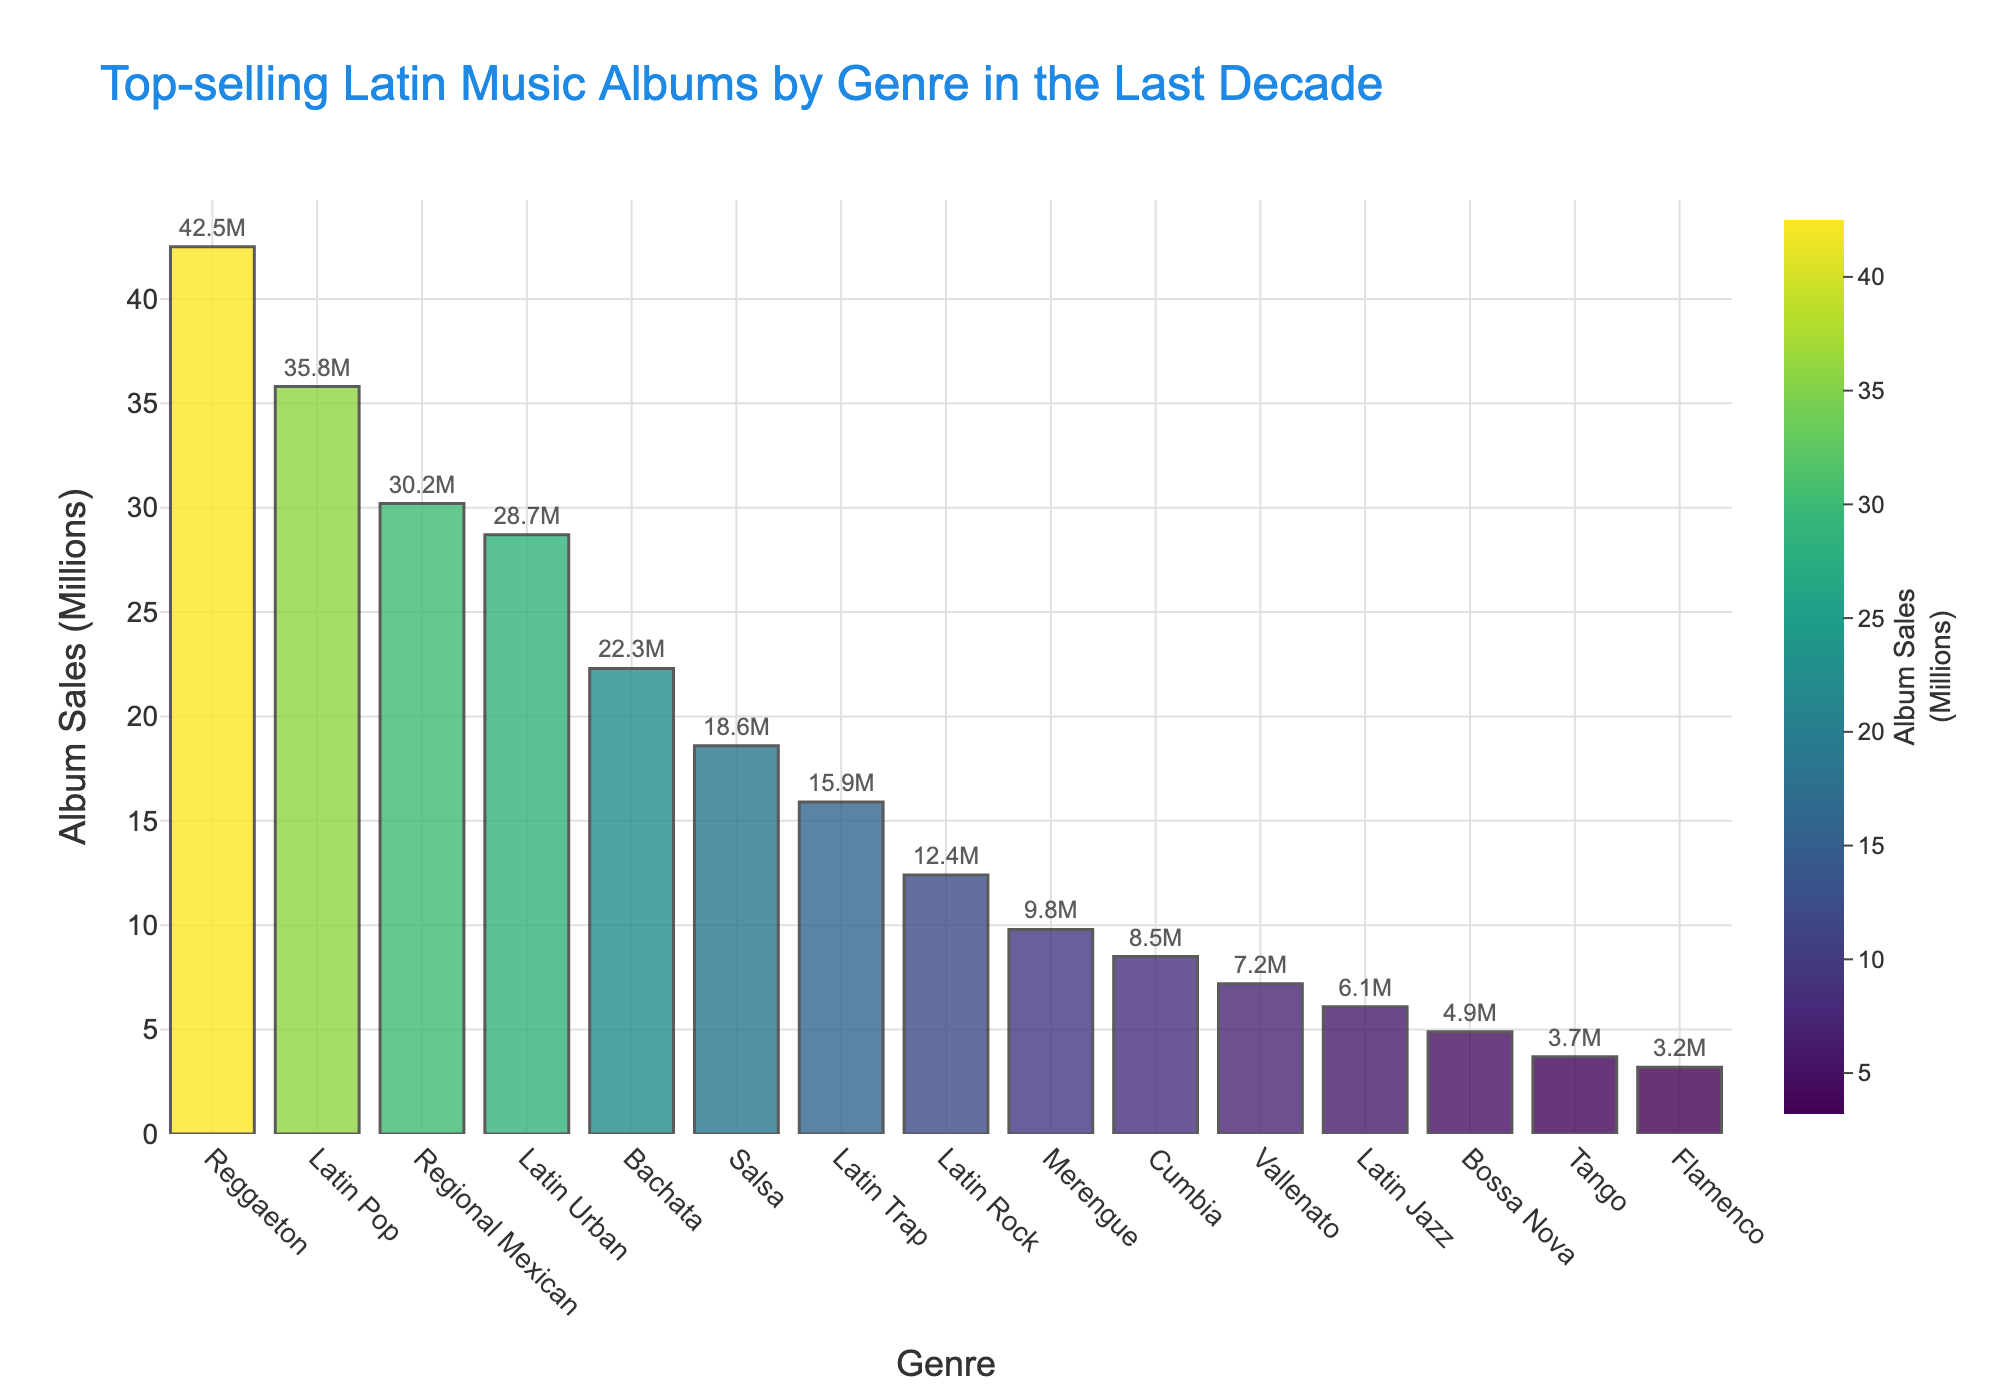What is the top-selling genre? The bar chart clearly shows the height of the bars. The Reggaeton bar is the tallest, indicating it has the highest album sales.
Answer: Reggaeton How many genres have album sales above 20 million? By visually examining the bar heights and their corresponding values, we can count the genres with bars taller than the 20 million mark: Reggaeton, Latin Pop, Regional Mexican, Latin Urban, and Bachata.
Answer: 5 What is the difference in album sales between Reggaeton and Latin Trap? The bar for Reggaeton is labeled as 42.5 million, and the bar for Latin Trap is labeled as 15.9 million. Subtracting these values gives: 42.5 - 15.9 = 26.6.
Answer: 26.6 million What are the three least selling genres? The shortest bars indicate the least album sales, and from the chart, the three shortest bars are labeled Tango, Flamenco, and Bossa Nova.
Answer: Tango, Flamenco, Bossa Nova Which genre is closest in sales to Latin Urban? The Latin Urban bar is labeled as 28.7 million. By comparing the heights and values of the other bars, we see that Regional Mexican at 30.2 million is the closest.
Answer: Regional Mexican Which genre has a bar colored in the darkest shade? The Reggaeton bar has the highest sales and is colored in the darkest shade of the Viridis color scale used in the chart.
Answer: Reggaeton What is the total album sales for Salsa and Merengue? Salsa has 18.6 million, and Merengue has 9.8 million. Adding these values gives: 18.6 + 9.8 = 28.4.
Answer: 28.4 million By how much does Latin Jazz exceed Tango in album sales? Latin Jazz is labeled at 6.1 million, and Tango is at 3.7 million. The difference is: 6.1 - 3.7 = 2.4.
Answer: 2.4 million Which genre has nearly half the sales of Latin Pop? Latin Pop sales are 35.8 million. Half of this value is 35.8 / 2 = 17.9 million. The closest to this value are Salsa (18.6 million) and Latin Trap (15.9 million). Salsa is slightly closer.
Answer: Salsa 